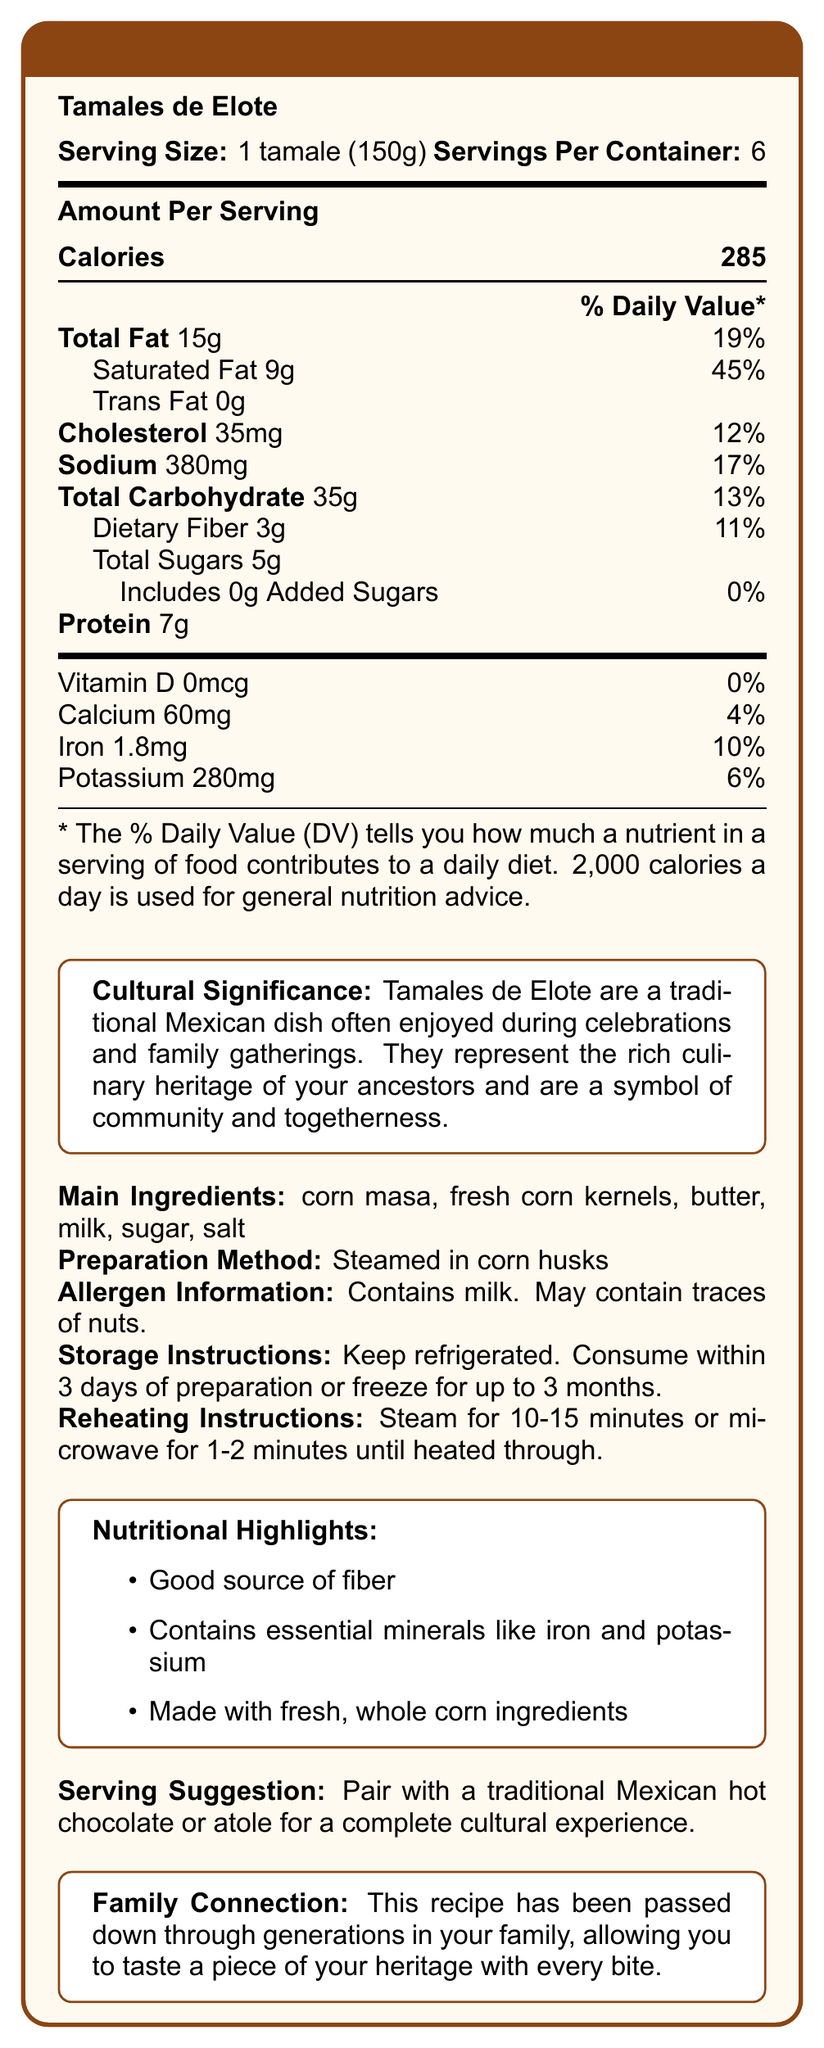What is the name of the dish? The document clearly states "Tamales de Elote" under the Nutrition Facts title.
Answer: Tamales de Elote What is the serving size of Tamales de Elote? The serving size is listed at the beginning of the document as "1 tamale (150g)".
Answer: 1 tamale (150g) How many calories are there in one serving of Tamales de Elote? The document lists "Calories 285" under the "Amount Per Serving" section.
Answer: 285 What percentage of the daily value is provided by the total fat content? Under "Total Fat", it specifies 19% of the daily value.
Answer: 19% List the main ingredients of Tamales de Elote. The main ingredients are listed as "corn masa, fresh corn kernels, butter, milk, sugar, salt".
Answer: Corn masa, fresh corn kernels, butter, milk, sugar, salt How is Tamales de Elote prepared? A. Fried B. Grilled C. Steamed D. Baked The preparation method mentioned in the document is "Steamed in corn husks".
Answer: C. Steamed Which of the following nutrients is present in the highest amount per serving? A. Sodium B. Calcium C. Protein D. Cholesterol Sodium is listed as 380mg, which is the highest amount compared to calcium (60mg), protein (7g), and cholesterol (35mg).
Answer: A. Sodium Do Tamales de Elote contain any added sugars? The document states that total added sugars are 0g.
Answer: No Is there any information on how long Tamales de Elote can be stored? The storage instructions state: "Keep refrigerated. Consume within 3 days of preparation or freeze for up to 3 months."
Answer: Yes What is the cultural significance of Tamales de Elote? The document includes a section on cultural significance detailing the importance of Tamales de Elote.
Answer: Tamales de Elote are a traditional Mexican dish often enjoyed during celebrations and family gatherings. They represent the rich culinary heritage of your ancestors and are a symbol of community and togetherness. Summarize the main idea of the document. The document contains various sections including a detailed nutritional breakdown, cultural relevance, preparation and storage instructions, allergen details, and suggestions for serving Tamales de Elote.
Answer: The document provides detailed nutritional information about Tamales de Elote, including serving size, calories, macro and micronutrients. It also explains the cultural significance, preparation methods, storage and reheating instructions, allergen information, and nutritional highlights. Does the document provide the specific vitamins and minerals present in Tamales de Elote? The document lists specific vitamins (such as Vitamin D) and minerals (like calcium, iron, and potassium), along with their amounts and daily values.
Answer: Yes Who passed down the Tamales de Elote recipe? The document mentions that the recipe has been passed down through generations in the family but does not provide information on the individual who passed it down.
Answer: Cannot be determined 